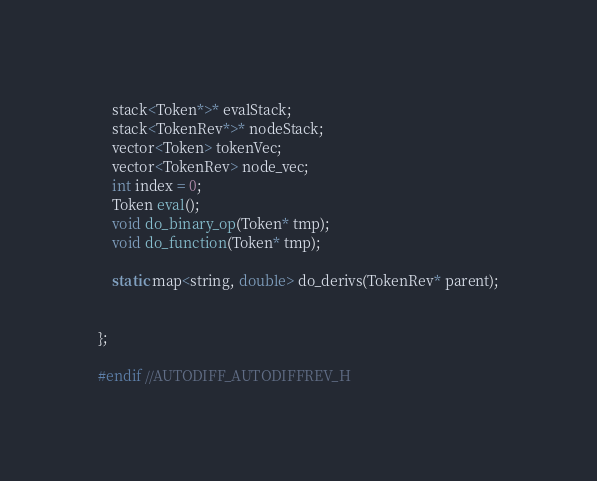Convert code to text. <code><loc_0><loc_0><loc_500><loc_500><_C_>    stack<Token*>* evalStack;
    stack<TokenRev*>* nodeStack;
    vector<Token> tokenVec;
    vector<TokenRev> node_vec;
    int index = 0;
    Token eval();
    void do_binary_op(Token* tmp);
    void do_function(Token* tmp);

    static map<string, double> do_derivs(TokenRev* parent);


};

#endif //AUTODIFF_AUTODIFFREV_H
</code> 